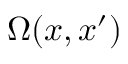<formula> <loc_0><loc_0><loc_500><loc_500>\Omega ( x , x ^ { \prime } )</formula> 